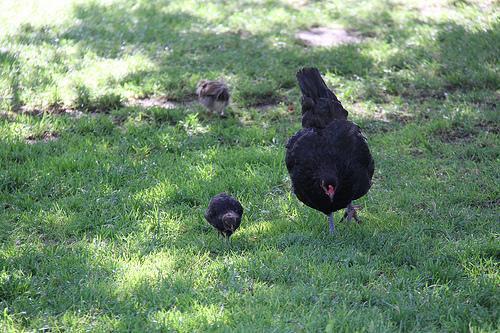How many chickens are there?
Give a very brief answer. 2. 